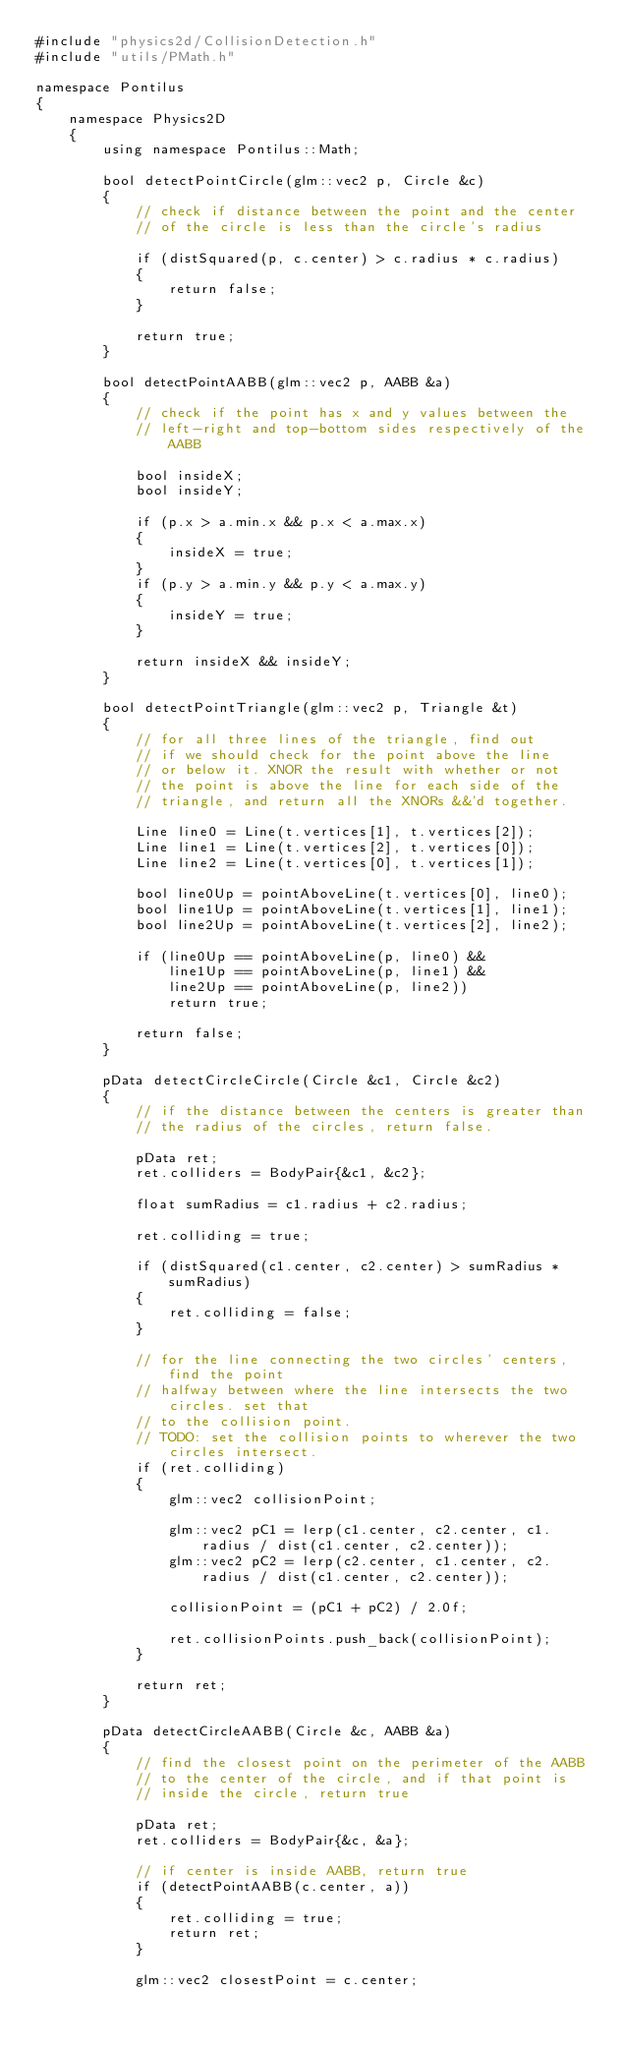Convert code to text. <code><loc_0><loc_0><loc_500><loc_500><_C++_>#include "physics2d/CollisionDetection.h"
#include "utils/PMath.h"

namespace Pontilus
{
    namespace Physics2D
    {
        using namespace Pontilus::Math;

        bool detectPointCircle(glm::vec2 p, Circle &c)
        {
            // check if distance between the point and the center 
            // of the circle is less than the circle's radius

            if (distSquared(p, c.center) > c.radius * c.radius)
            {
                return false;
            }

            return true;
        }

        bool detectPointAABB(glm::vec2 p, AABB &a)
        {
            // check if the point has x and y values between the
            // left-right and top-bottom sides respectively of the AABB

            bool insideX;
            bool insideY;

            if (p.x > a.min.x && p.x < a.max.x)
            {
                insideX = true;
            }
            if (p.y > a.min.y && p.y < a.max.y)
            {
                insideY = true;
            }

            return insideX && insideY;
        }

        bool detectPointTriangle(glm::vec2 p, Triangle &t)
        {
            // for all three lines of the triangle, find out
            // if we should check for the point above the line
            // or below it. XNOR the result with whether or not
            // the point is above the line for each side of the 
            // triangle, and return all the XNORs &&'d together.
            
            Line line0 = Line(t.vertices[1], t.vertices[2]);
            Line line1 = Line(t.vertices[2], t.vertices[0]);
            Line line2 = Line(t.vertices[0], t.vertices[1]);

            bool line0Up = pointAboveLine(t.vertices[0], line0);
            bool line1Up = pointAboveLine(t.vertices[1], line1);
            bool line2Up = pointAboveLine(t.vertices[2], line2);

            if (line0Up == pointAboveLine(p, line0) && 
                line1Up == pointAboveLine(p, line1) &&
                line2Up == pointAboveLine(p, line2))
                return true;
            
            return false;
        }

        pData detectCircleCircle(Circle &c1, Circle &c2)
        {
            // if the distance between the centers is greater than 
            // the radius of the circles, return false.

            pData ret;
            ret.colliders = BodyPair{&c1, &c2};

            float sumRadius = c1.radius + c2.radius;

            ret.colliding = true;

            if (distSquared(c1.center, c2.center) > sumRadius * sumRadius)
            {
                ret.colliding = false;
            }

            // for the line connecting the two circles' centers, find the point
            // halfway between where the line intersects the two circles. set that
            // to the collision point.
            // TODO: set the collision points to wherever the two circles intersect.
            if (ret.colliding)
            {
                glm::vec2 collisionPoint;

                glm::vec2 pC1 = lerp(c1.center, c2.center, c1.radius / dist(c1.center, c2.center));
                glm::vec2 pC2 = lerp(c2.center, c1.center, c2.radius / dist(c1.center, c2.center));

                collisionPoint = (pC1 + pC2) / 2.0f;

                ret.collisionPoints.push_back(collisionPoint);
            }
            
            return ret;
        }

        pData detectCircleAABB(Circle &c, AABB &a)
        {
            // find the closest point on the perimeter of the AABB
            // to the center of the circle, and if that point is
            // inside the circle, return true

            pData ret;
            ret.colliders = BodyPair{&c, &a};

            // if center is inside AABB, return true
            if (detectPointAABB(c.center, a)) 
            {
                ret.colliding = true;
                return ret;
            }

            glm::vec2 closestPoint = c.center;
</code> 